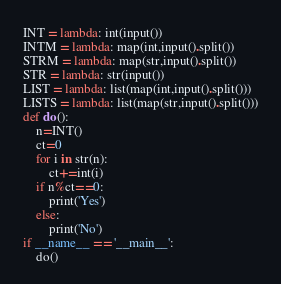<code> <loc_0><loc_0><loc_500><loc_500><_Python_>INT = lambda: int(input())
INTM = lambda: map(int,input().split())
STRM = lambda: map(str,input().split())
STR = lambda: str(input())
LIST = lambda: list(map(int,input().split()))
LISTS = lambda: list(map(str,input().split()))
def do():
    n=INT()
    ct=0
    for i in str(n):
        ct+=int(i)
    if n%ct==0:
        print('Yes')
    else:
        print('No')
if __name__ == '__main__':
    do()</code> 